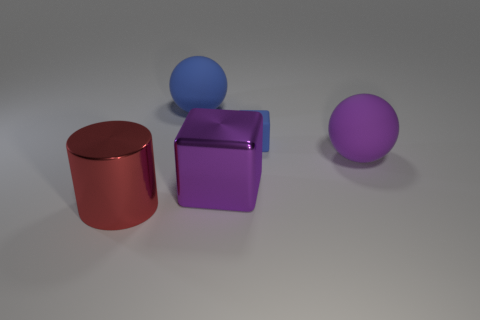Add 1 small blue matte blocks. How many objects exist? 6 Subtract all blocks. How many objects are left? 3 Add 3 red things. How many red things are left? 4 Add 2 big purple rubber spheres. How many big purple rubber spheres exist? 3 Subtract 1 blue blocks. How many objects are left? 4 Subtract all matte blocks. Subtract all matte blocks. How many objects are left? 3 